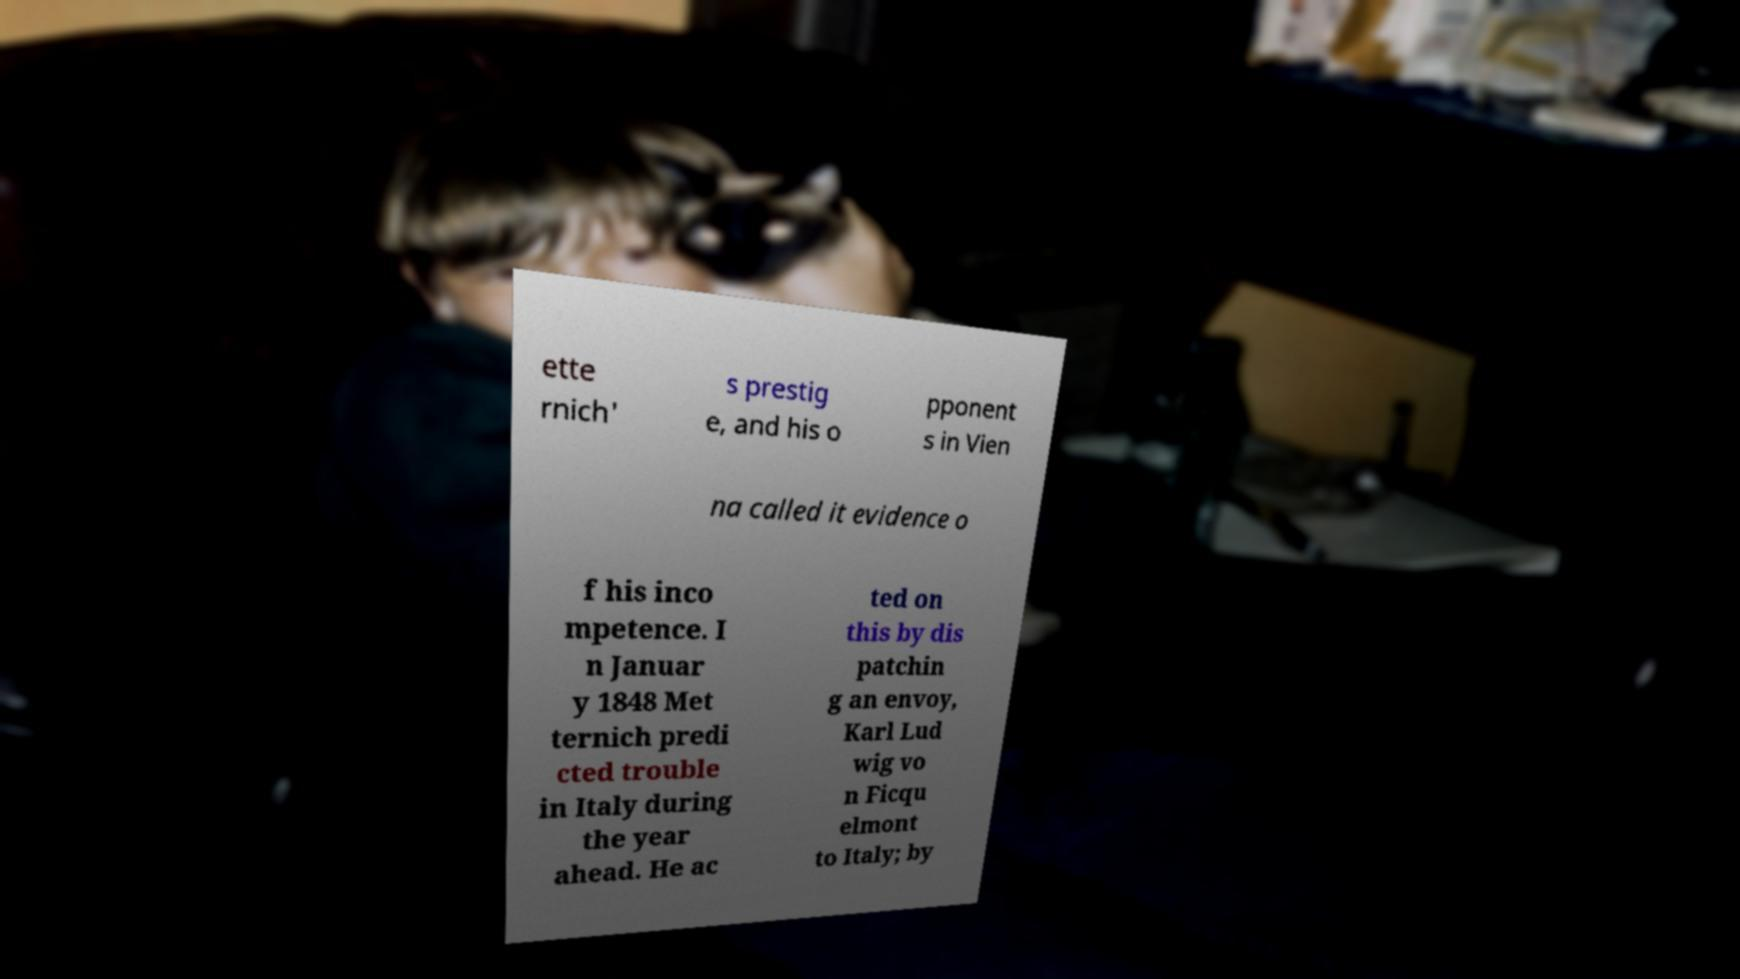Please read and relay the text visible in this image. What does it say? ette rnich' s prestig e, and his o pponent s in Vien na called it evidence o f his inco mpetence. I n Januar y 1848 Met ternich predi cted trouble in Italy during the year ahead. He ac ted on this by dis patchin g an envoy, Karl Lud wig vo n Ficqu elmont to Italy; by 